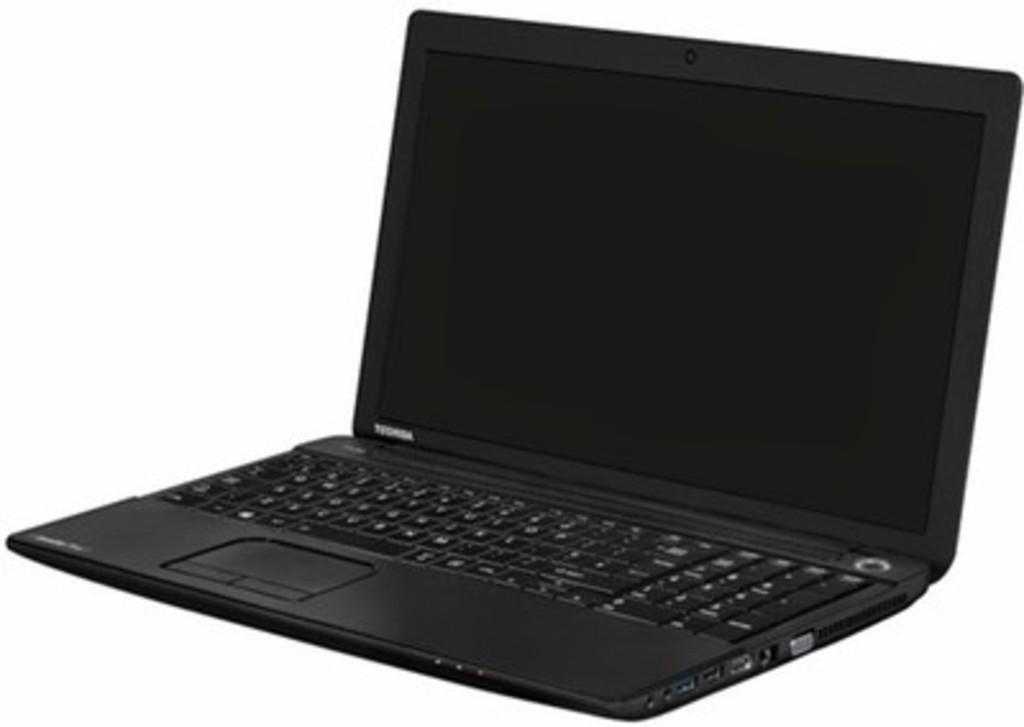<image>
Write a terse but informative summary of the picture. Black Toshiba laptop with a black screen in front of a white background. 